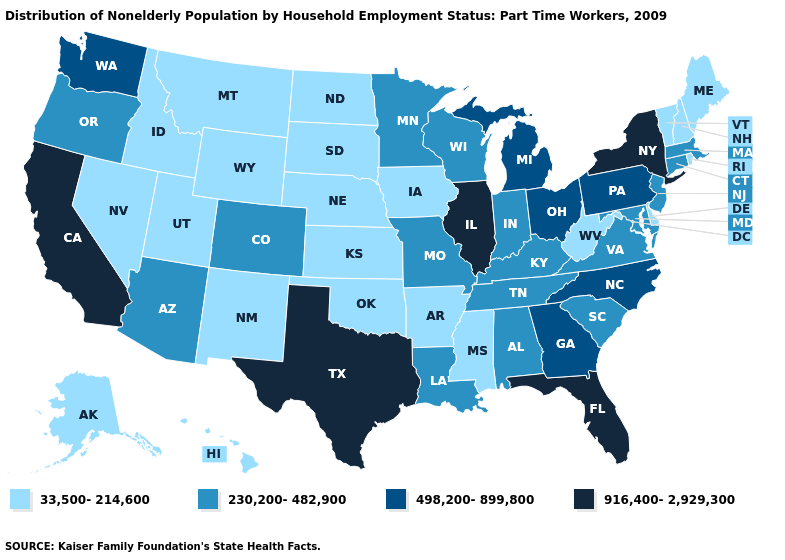Name the states that have a value in the range 33,500-214,600?
Give a very brief answer. Alaska, Arkansas, Delaware, Hawaii, Idaho, Iowa, Kansas, Maine, Mississippi, Montana, Nebraska, Nevada, New Hampshire, New Mexico, North Dakota, Oklahoma, Rhode Island, South Dakota, Utah, Vermont, West Virginia, Wyoming. Is the legend a continuous bar?
Keep it brief. No. Does the map have missing data?
Give a very brief answer. No. What is the lowest value in states that border Utah?
Keep it brief. 33,500-214,600. What is the value of Virginia?
Short answer required. 230,200-482,900. What is the lowest value in states that border New York?
Be succinct. 33,500-214,600. Name the states that have a value in the range 916,400-2,929,300?
Quick response, please. California, Florida, Illinois, New York, Texas. Does the map have missing data?
Quick response, please. No. Among the states that border Nebraska , which have the highest value?
Be succinct. Colorado, Missouri. Among the states that border Iowa , does Minnesota have the lowest value?
Be succinct. No. Name the states that have a value in the range 916,400-2,929,300?
Write a very short answer. California, Florida, Illinois, New York, Texas. What is the highest value in states that border Maine?
Give a very brief answer. 33,500-214,600. Among the states that border Nevada , which have the lowest value?
Answer briefly. Idaho, Utah. Which states have the lowest value in the USA?
Concise answer only. Alaska, Arkansas, Delaware, Hawaii, Idaho, Iowa, Kansas, Maine, Mississippi, Montana, Nebraska, Nevada, New Hampshire, New Mexico, North Dakota, Oklahoma, Rhode Island, South Dakota, Utah, Vermont, West Virginia, Wyoming. Does Indiana have a higher value than Oregon?
Concise answer only. No. 